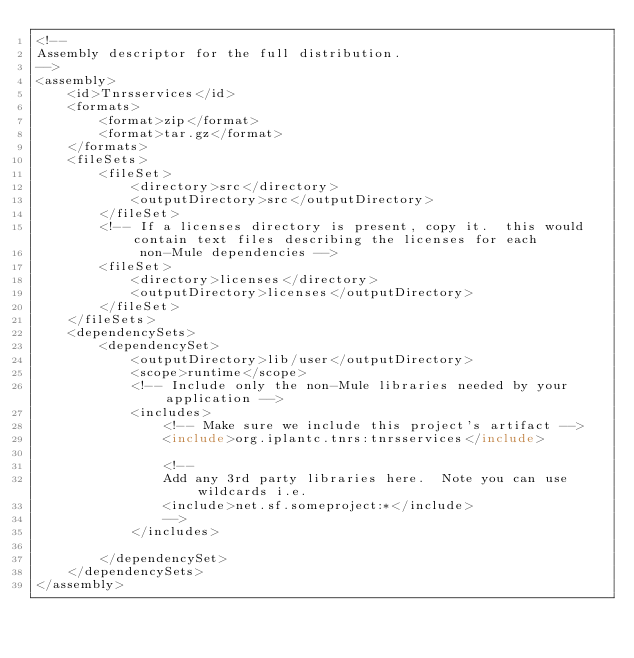<code> <loc_0><loc_0><loc_500><loc_500><_XML_><!--
Assembly descriptor for the full distribution.
-->
<assembly>
    <id>Tnrsservices</id>
    <formats>
        <format>zip</format>
        <format>tar.gz</format>
    </formats>
    <fileSets>
        <fileSet>
            <directory>src</directory>
            <outputDirectory>src</outputDirectory>
        </fileSet>
        <!-- If a licenses directory is present, copy it.  this would contain text files describing the licenses for each
             non-Mule dependencies -->
        <fileSet>
            <directory>licenses</directory>
            <outputDirectory>licenses</outputDirectory>
        </fileSet>
    </fileSets>
    <dependencySets>
        <dependencySet>
            <outputDirectory>lib/user</outputDirectory>
            <scope>runtime</scope>
            <!-- Include only the non-Mule libraries needed by your application -->
            <includes>
                <!-- Make sure we include this project's artifact -->
                <include>org.iplantc.tnrs:tnrsservices</include>

                <!--
                Add any 3rd party libraries here.  Note you can use wildcards i.e.
                <include>net.sf.someproject:*</include>
                -->
            </includes>

        </dependencySet>
    </dependencySets>
</assembly></code> 